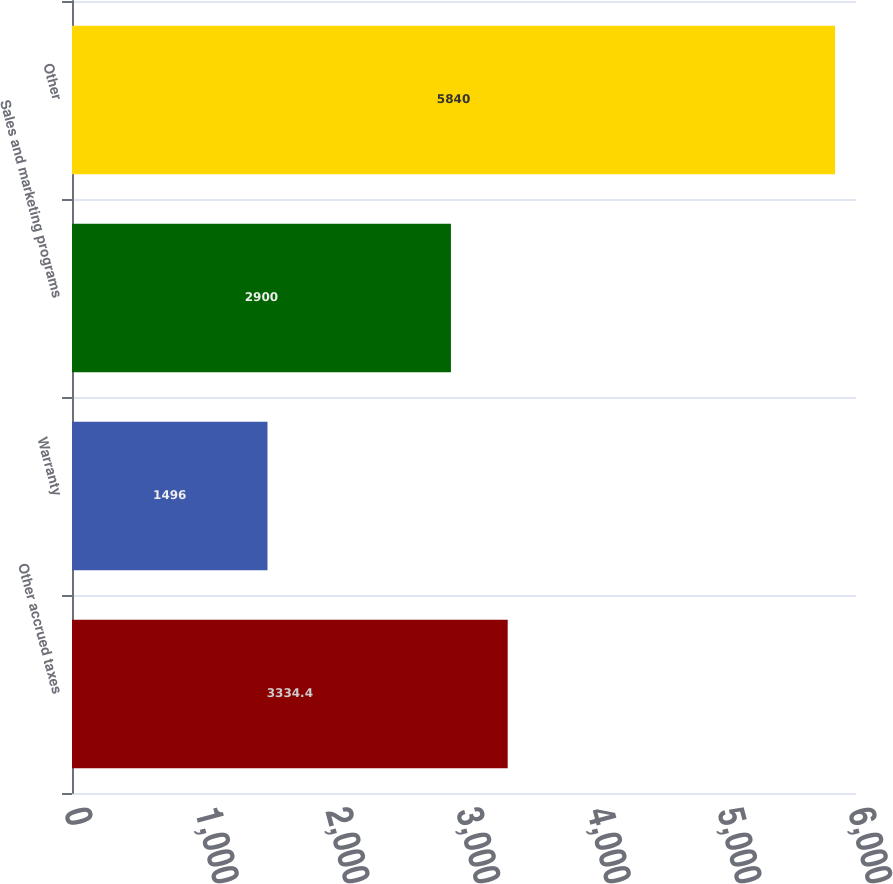<chart> <loc_0><loc_0><loc_500><loc_500><bar_chart><fcel>Other accrued taxes<fcel>Warranty<fcel>Sales and marketing programs<fcel>Other<nl><fcel>3334.4<fcel>1496<fcel>2900<fcel>5840<nl></chart> 